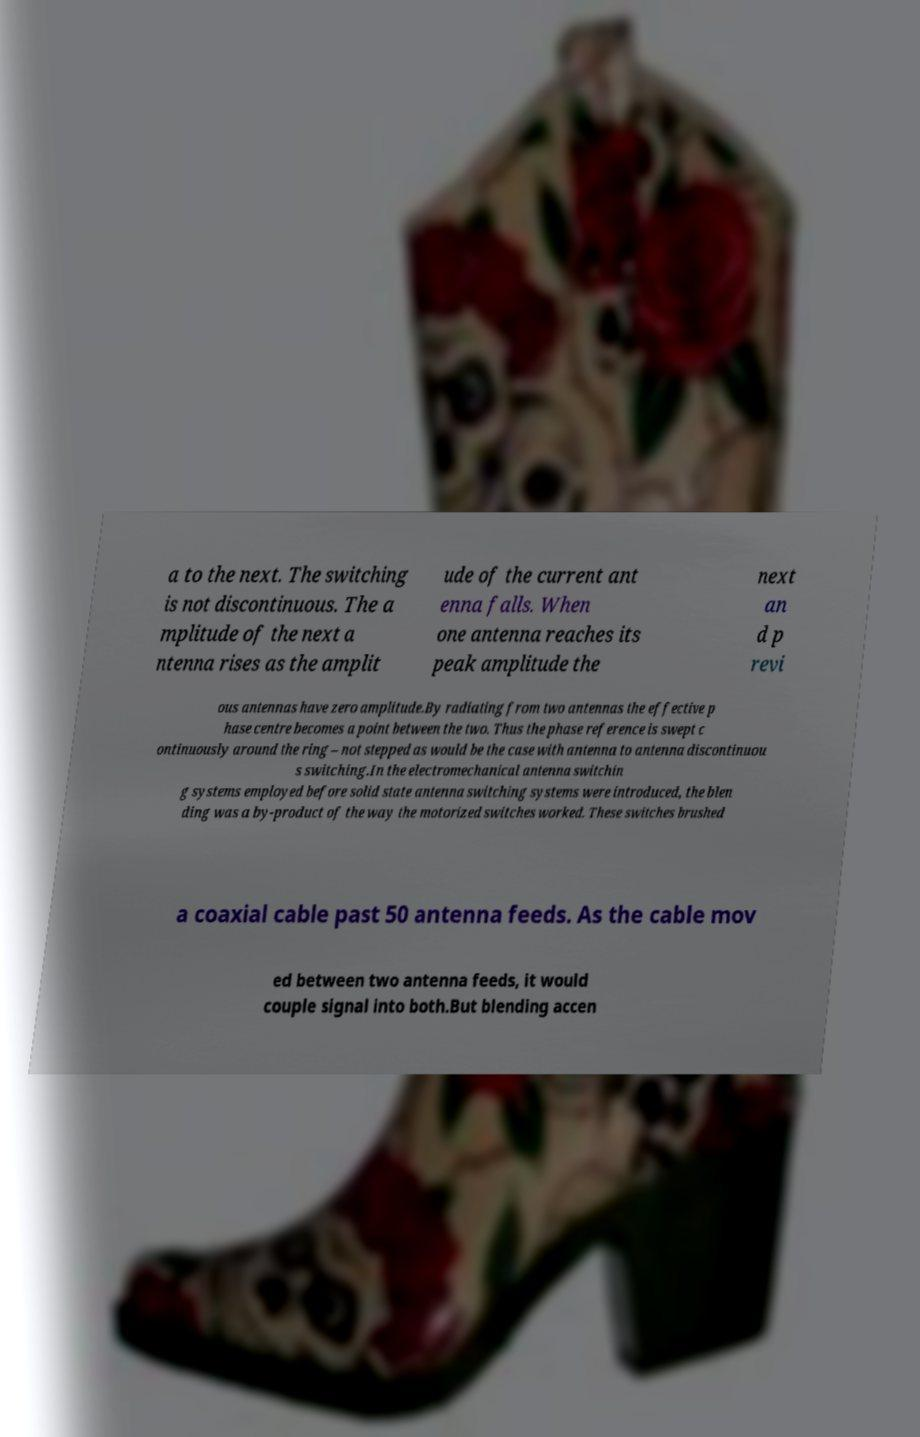Can you read and provide the text displayed in the image?This photo seems to have some interesting text. Can you extract and type it out for me? a to the next. The switching is not discontinuous. The a mplitude of the next a ntenna rises as the amplit ude of the current ant enna falls. When one antenna reaches its peak amplitude the next an d p revi ous antennas have zero amplitude.By radiating from two antennas the effective p hase centre becomes a point between the two. Thus the phase reference is swept c ontinuously around the ring – not stepped as would be the case with antenna to antenna discontinuou s switching.In the electromechanical antenna switchin g systems employed before solid state antenna switching systems were introduced, the blen ding was a by-product of the way the motorized switches worked. These switches brushed a coaxial cable past 50 antenna feeds. As the cable mov ed between two antenna feeds, it would couple signal into both.But blending accen 